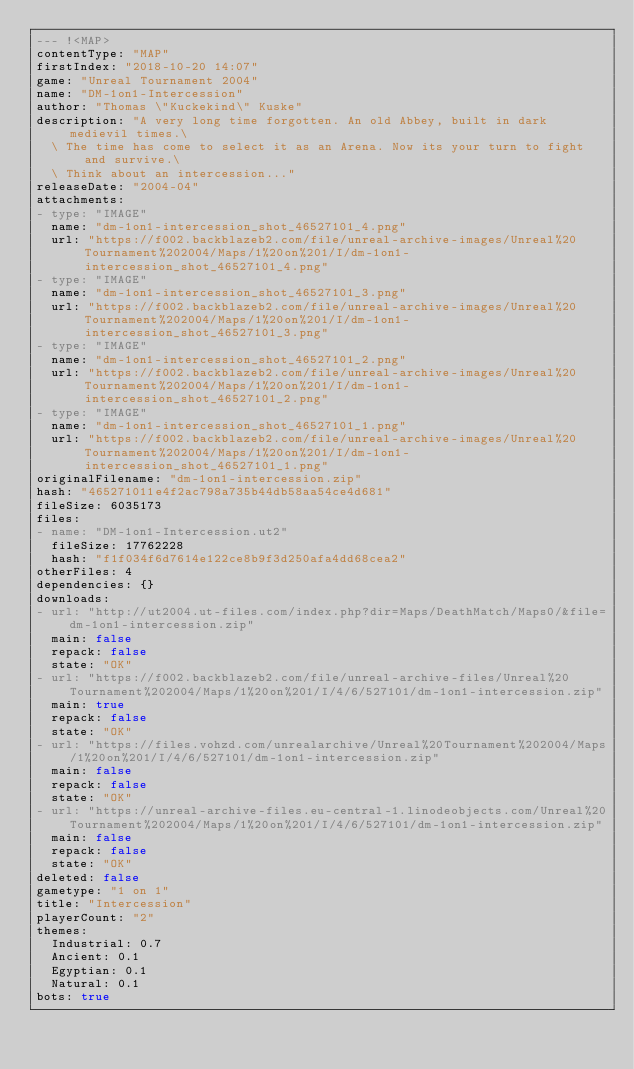<code> <loc_0><loc_0><loc_500><loc_500><_YAML_>--- !<MAP>
contentType: "MAP"
firstIndex: "2018-10-20 14:07"
game: "Unreal Tournament 2004"
name: "DM-1on1-Intercession"
author: "Thomas \"Kuckekind\" Kuske"
description: "A very long time forgotten. An old Abbey, built in dark medievil times.\
  \ The time has come to select it as an Arena. Now its your turn to fight and survive.\
  \ Think about an intercession..."
releaseDate: "2004-04"
attachments:
- type: "IMAGE"
  name: "dm-1on1-intercession_shot_46527101_4.png"
  url: "https://f002.backblazeb2.com/file/unreal-archive-images/Unreal%20Tournament%202004/Maps/1%20on%201/I/dm-1on1-intercession_shot_46527101_4.png"
- type: "IMAGE"
  name: "dm-1on1-intercession_shot_46527101_3.png"
  url: "https://f002.backblazeb2.com/file/unreal-archive-images/Unreal%20Tournament%202004/Maps/1%20on%201/I/dm-1on1-intercession_shot_46527101_3.png"
- type: "IMAGE"
  name: "dm-1on1-intercession_shot_46527101_2.png"
  url: "https://f002.backblazeb2.com/file/unreal-archive-images/Unreal%20Tournament%202004/Maps/1%20on%201/I/dm-1on1-intercession_shot_46527101_2.png"
- type: "IMAGE"
  name: "dm-1on1-intercession_shot_46527101_1.png"
  url: "https://f002.backblazeb2.com/file/unreal-archive-images/Unreal%20Tournament%202004/Maps/1%20on%201/I/dm-1on1-intercession_shot_46527101_1.png"
originalFilename: "dm-1on1-intercession.zip"
hash: "465271011e4f2ac798a735b44db58aa54ce4d681"
fileSize: 6035173
files:
- name: "DM-1on1-Intercession.ut2"
  fileSize: 17762228
  hash: "f1f034f6d7614e122ce8b9f3d250afa4dd68cea2"
otherFiles: 4
dependencies: {}
downloads:
- url: "http://ut2004.ut-files.com/index.php?dir=Maps/DeathMatch/Maps0/&file=dm-1on1-intercession.zip"
  main: false
  repack: false
  state: "OK"
- url: "https://f002.backblazeb2.com/file/unreal-archive-files/Unreal%20Tournament%202004/Maps/1%20on%201/I/4/6/527101/dm-1on1-intercession.zip"
  main: true
  repack: false
  state: "OK"
- url: "https://files.vohzd.com/unrealarchive/Unreal%20Tournament%202004/Maps/1%20on%201/I/4/6/527101/dm-1on1-intercession.zip"
  main: false
  repack: false
  state: "OK"
- url: "https://unreal-archive-files.eu-central-1.linodeobjects.com/Unreal%20Tournament%202004/Maps/1%20on%201/I/4/6/527101/dm-1on1-intercession.zip"
  main: false
  repack: false
  state: "OK"
deleted: false
gametype: "1 on 1"
title: "Intercession"
playerCount: "2"
themes:
  Industrial: 0.7
  Ancient: 0.1
  Egyptian: 0.1
  Natural: 0.1
bots: true
</code> 